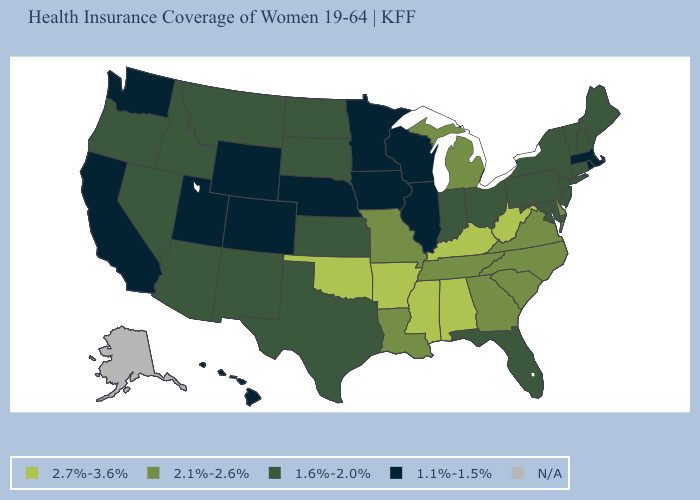Name the states that have a value in the range 2.1%-2.6%?
Write a very short answer. Delaware, Georgia, Louisiana, Michigan, Missouri, North Carolina, South Carolina, Tennessee, Virginia. Does Florida have the lowest value in the South?
Be succinct. Yes. What is the value of Wyoming?
Keep it brief. 1.1%-1.5%. Name the states that have a value in the range N/A?
Be succinct. Alaska. What is the lowest value in states that border New York?
Give a very brief answer. 1.1%-1.5%. What is the value of Iowa?
Answer briefly. 1.1%-1.5%. What is the value of Massachusetts?
Be succinct. 1.1%-1.5%. What is the lowest value in the Northeast?
Answer briefly. 1.1%-1.5%. Among the states that border Connecticut , which have the lowest value?
Concise answer only. Massachusetts, Rhode Island. What is the value of Delaware?
Concise answer only. 2.1%-2.6%. What is the lowest value in the MidWest?
Write a very short answer. 1.1%-1.5%. Which states hav the highest value in the South?
Keep it brief. Alabama, Arkansas, Kentucky, Mississippi, Oklahoma, West Virginia. What is the value of Arkansas?
Give a very brief answer. 2.7%-3.6%. What is the lowest value in states that border New Jersey?
Write a very short answer. 1.6%-2.0%. What is the value of New York?
Answer briefly. 1.6%-2.0%. 